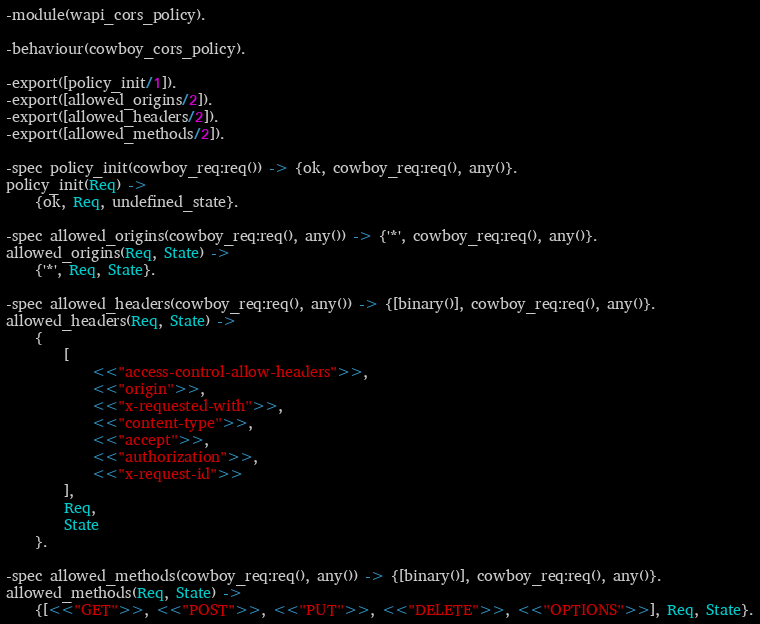<code> <loc_0><loc_0><loc_500><loc_500><_Erlang_>-module(wapi_cors_policy).

-behaviour(cowboy_cors_policy).

-export([policy_init/1]).
-export([allowed_origins/2]).
-export([allowed_headers/2]).
-export([allowed_methods/2]).

-spec policy_init(cowboy_req:req()) -> {ok, cowboy_req:req(), any()}.
policy_init(Req) ->
    {ok, Req, undefined_state}.

-spec allowed_origins(cowboy_req:req(), any()) -> {'*', cowboy_req:req(), any()}.
allowed_origins(Req, State) ->
    {'*', Req, State}.

-spec allowed_headers(cowboy_req:req(), any()) -> {[binary()], cowboy_req:req(), any()}.
allowed_headers(Req, State) ->
    {
        [
            <<"access-control-allow-headers">>,
            <<"origin">>,
            <<"x-requested-with">>,
            <<"content-type">>,
            <<"accept">>,
            <<"authorization">>,
            <<"x-request-id">>
        ],
        Req,
        State
    }.

-spec allowed_methods(cowboy_req:req(), any()) -> {[binary()], cowboy_req:req(), any()}.
allowed_methods(Req, State) ->
    {[<<"GET">>, <<"POST">>, <<"PUT">>, <<"DELETE">>, <<"OPTIONS">>], Req, State}.
</code> 